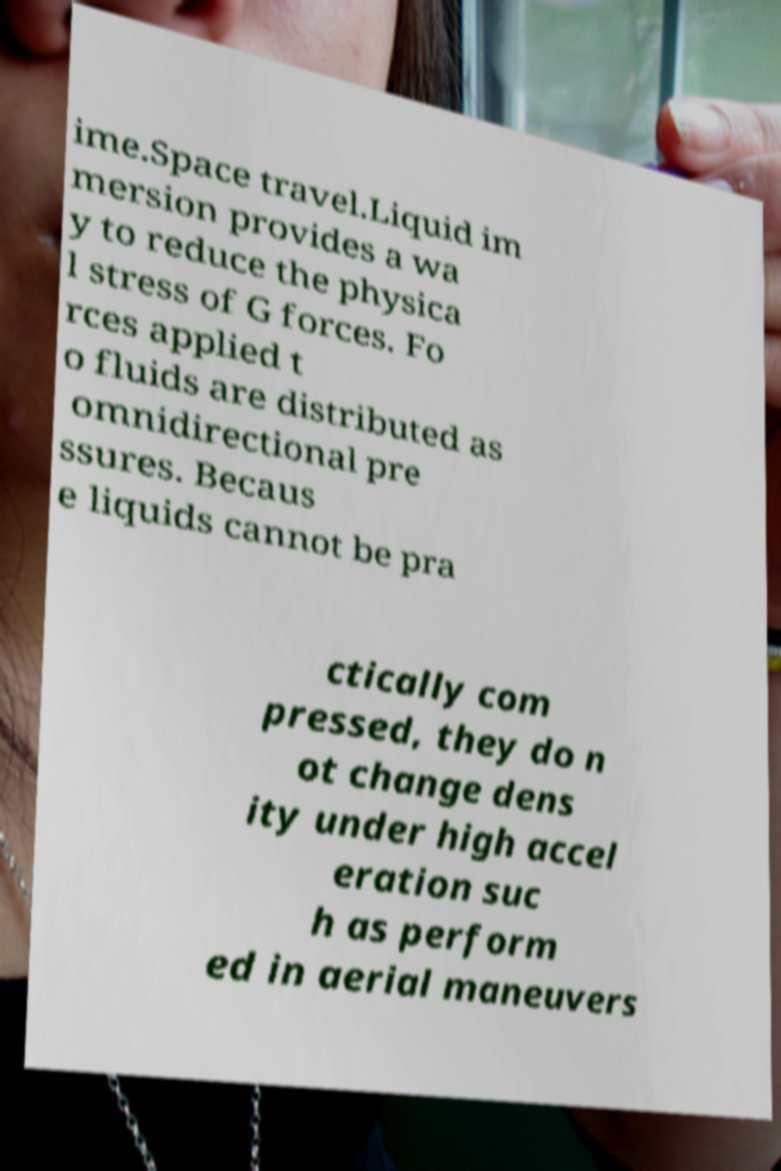Please identify and transcribe the text found in this image. ime.Space travel.Liquid im mersion provides a wa y to reduce the physica l stress of G forces. Fo rces applied t o fluids are distributed as omnidirectional pre ssures. Becaus e liquids cannot be pra ctically com pressed, they do n ot change dens ity under high accel eration suc h as perform ed in aerial maneuvers 